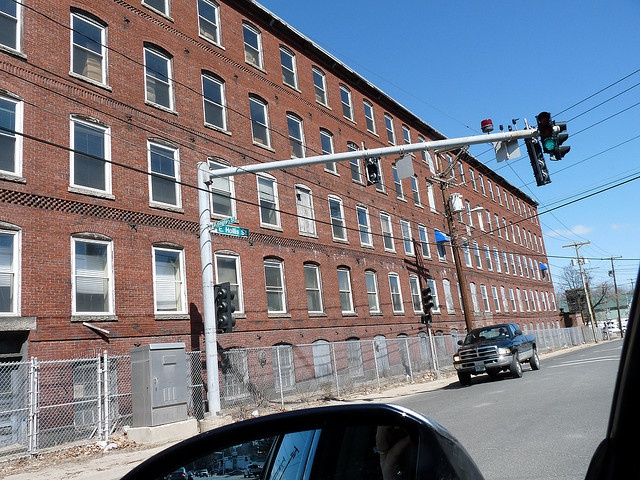Describe the objects in this image and their specific colors. I can see car in blue, black, teal, and navy tones, car in blue, black, gray, and darkgray tones, truck in blue, black, gray, and darkgray tones, traffic light in blue, black, lightblue, teal, and gray tones, and people in blue, black, purple, and gray tones in this image. 